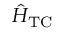<formula> <loc_0><loc_0><loc_500><loc_500>\hat { H } _ { T C }</formula> 